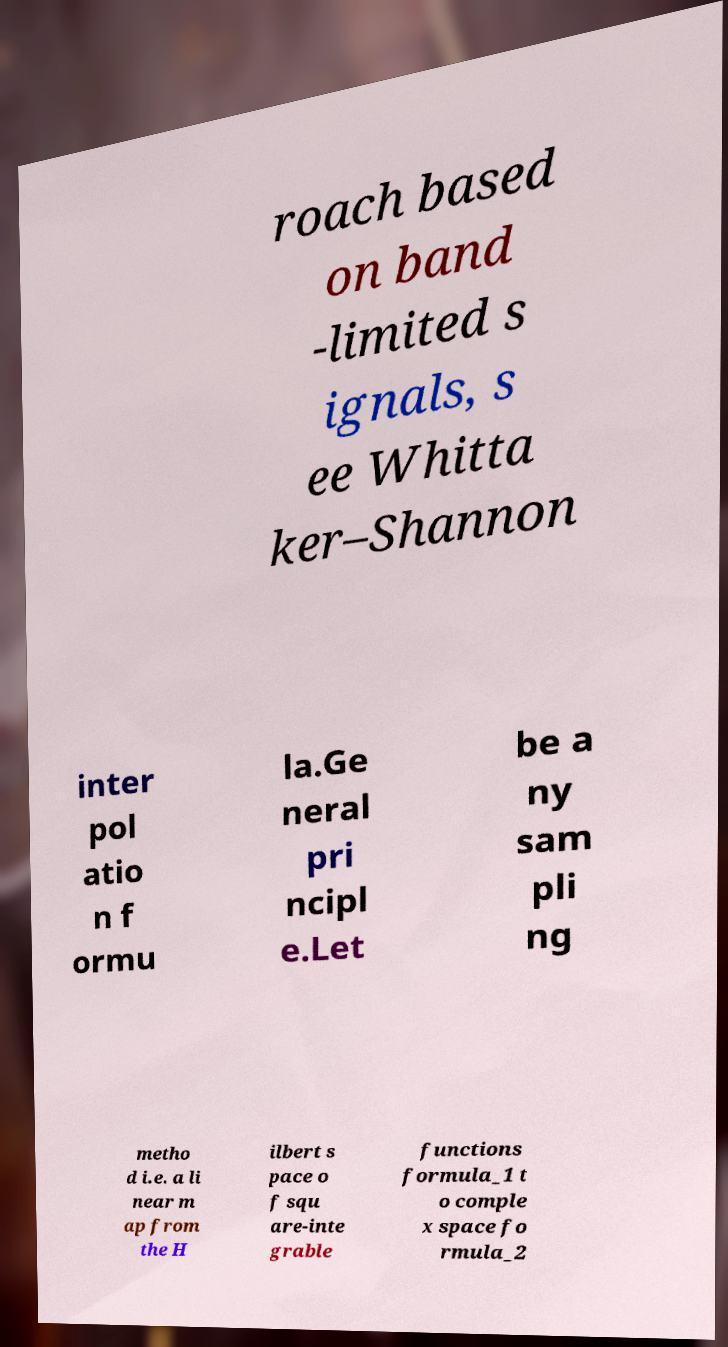Could you assist in decoding the text presented in this image and type it out clearly? roach based on band -limited s ignals, s ee Whitta ker–Shannon inter pol atio n f ormu la.Ge neral pri ncipl e.Let be a ny sam pli ng metho d i.e. a li near m ap from the H ilbert s pace o f squ are-inte grable functions formula_1 t o comple x space fo rmula_2 